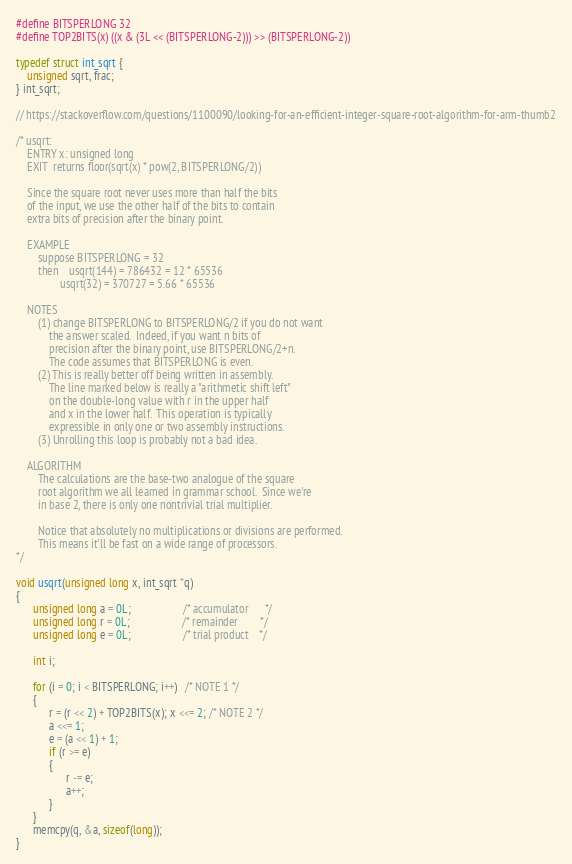<code> <loc_0><loc_0><loc_500><loc_500><_C_>#define BITSPERLONG 32
#define TOP2BITS(x) ((x & (3L << (BITSPERLONG-2))) >> (BITSPERLONG-2))

typedef struct int_sqrt {
    unsigned sqrt, frac;
} int_sqrt;

// https://stackoverflow.com/questions/1100090/looking-for-an-efficient-integer-square-root-algorithm-for-arm-thumb2

/* usqrt:
    ENTRY x: unsigned long
    EXIT  returns floor(sqrt(x) * pow(2, BITSPERLONG/2))

    Since the square root never uses more than half the bits
    of the input, we use the other half of the bits to contain
    extra bits of precision after the binary point.

    EXAMPLE
        suppose BITSPERLONG = 32
        then    usqrt(144) = 786432 = 12 * 65536
                usqrt(32) = 370727 = 5.66 * 65536

    NOTES
        (1) change BITSPERLONG to BITSPERLONG/2 if you do not want
            the answer scaled.  Indeed, if you want n bits of
            precision after the binary point, use BITSPERLONG/2+n.
            The code assumes that BITSPERLONG is even.
        (2) This is really better off being written in assembly.
            The line marked below is really a "arithmetic shift left"
            on the double-long value with r in the upper half
            and x in the lower half.  This operation is typically
            expressible in only one or two assembly instructions.
        (3) Unrolling this loop is probably not a bad idea.

    ALGORITHM
        The calculations are the base-two analogue of the square
        root algorithm we all learned in grammar school.  Since we're
        in base 2, there is only one nontrivial trial multiplier.

        Notice that absolutely no multiplications or divisions are performed.
        This means it'll be fast on a wide range of processors.
*/

void usqrt(unsigned long x, int_sqrt *q)
{
      unsigned long a = 0L;                   /* accumulator      */
      unsigned long r = 0L;                   /* remainder        */
      unsigned long e = 0L;                   /* trial product    */

      int i;

      for (i = 0; i < BITSPERLONG; i++)   /* NOTE 1 */
      {
            r = (r << 2) + TOP2BITS(x); x <<= 2; /* NOTE 2 */
            a <<= 1;
            e = (a << 1) + 1;
            if (r >= e)
            {
                  r -= e;
                  a++;
            }
      }
      memcpy(q, &a, sizeof(long));
}
</code> 